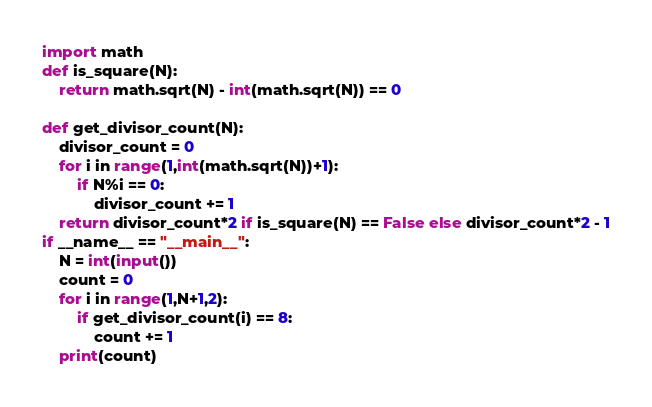Convert code to text. <code><loc_0><loc_0><loc_500><loc_500><_Python_>import math
def is_square(N):
    return math.sqrt(N) - int(math.sqrt(N)) == 0

def get_divisor_count(N):
    divisor_count = 0
    for i in range(1,int(math.sqrt(N))+1):
        if N%i == 0:
            divisor_count += 1
    return divisor_count*2 if is_square(N) == False else divisor_count*2 - 1
if __name__ == "__main__":
    N = int(input())
    count = 0
    for i in range(1,N+1,2):
        if get_divisor_count(i) == 8:
            count += 1
    print(count)</code> 